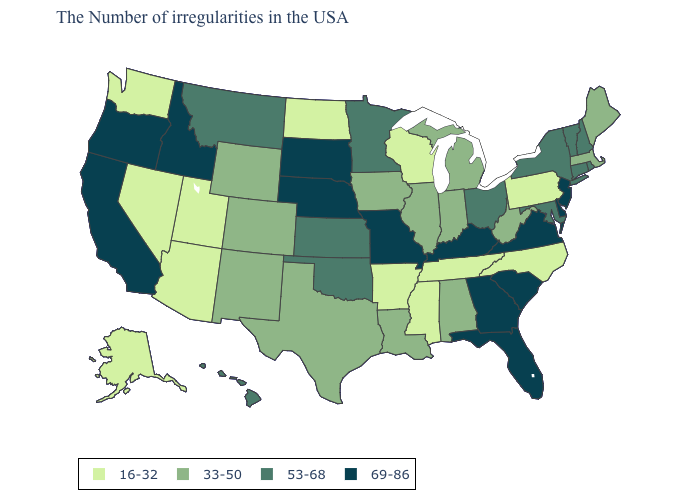What is the lowest value in the USA?
Answer briefly. 16-32. What is the lowest value in the West?
Be succinct. 16-32. What is the value of Idaho?
Write a very short answer. 69-86. Is the legend a continuous bar?
Short answer required. No. Does New York have the highest value in the Northeast?
Answer briefly. No. Name the states that have a value in the range 69-86?
Short answer required. New Jersey, Delaware, Virginia, South Carolina, Florida, Georgia, Kentucky, Missouri, Nebraska, South Dakota, Idaho, California, Oregon. Name the states that have a value in the range 16-32?
Concise answer only. Pennsylvania, North Carolina, Tennessee, Wisconsin, Mississippi, Arkansas, North Dakota, Utah, Arizona, Nevada, Washington, Alaska. What is the value of New York?
Quick response, please. 53-68. Does Montana have a lower value than Missouri?
Answer briefly. Yes. What is the highest value in the MidWest ?
Concise answer only. 69-86. Among the states that border Wyoming , which have the highest value?
Concise answer only. Nebraska, South Dakota, Idaho. Does Wisconsin have the highest value in the MidWest?
Concise answer only. No. Among the states that border New Mexico , does Utah have the lowest value?
Keep it brief. Yes. Name the states that have a value in the range 69-86?
Give a very brief answer. New Jersey, Delaware, Virginia, South Carolina, Florida, Georgia, Kentucky, Missouri, Nebraska, South Dakota, Idaho, California, Oregon. Name the states that have a value in the range 53-68?
Concise answer only. Rhode Island, New Hampshire, Vermont, Connecticut, New York, Maryland, Ohio, Minnesota, Kansas, Oklahoma, Montana, Hawaii. 